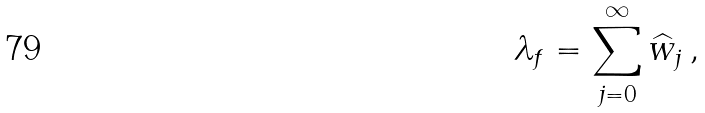<formula> <loc_0><loc_0><loc_500><loc_500>\lambda _ { f } = \sum _ { j = 0 } ^ { \infty } \widehat { w } _ { j } \, ,</formula> 